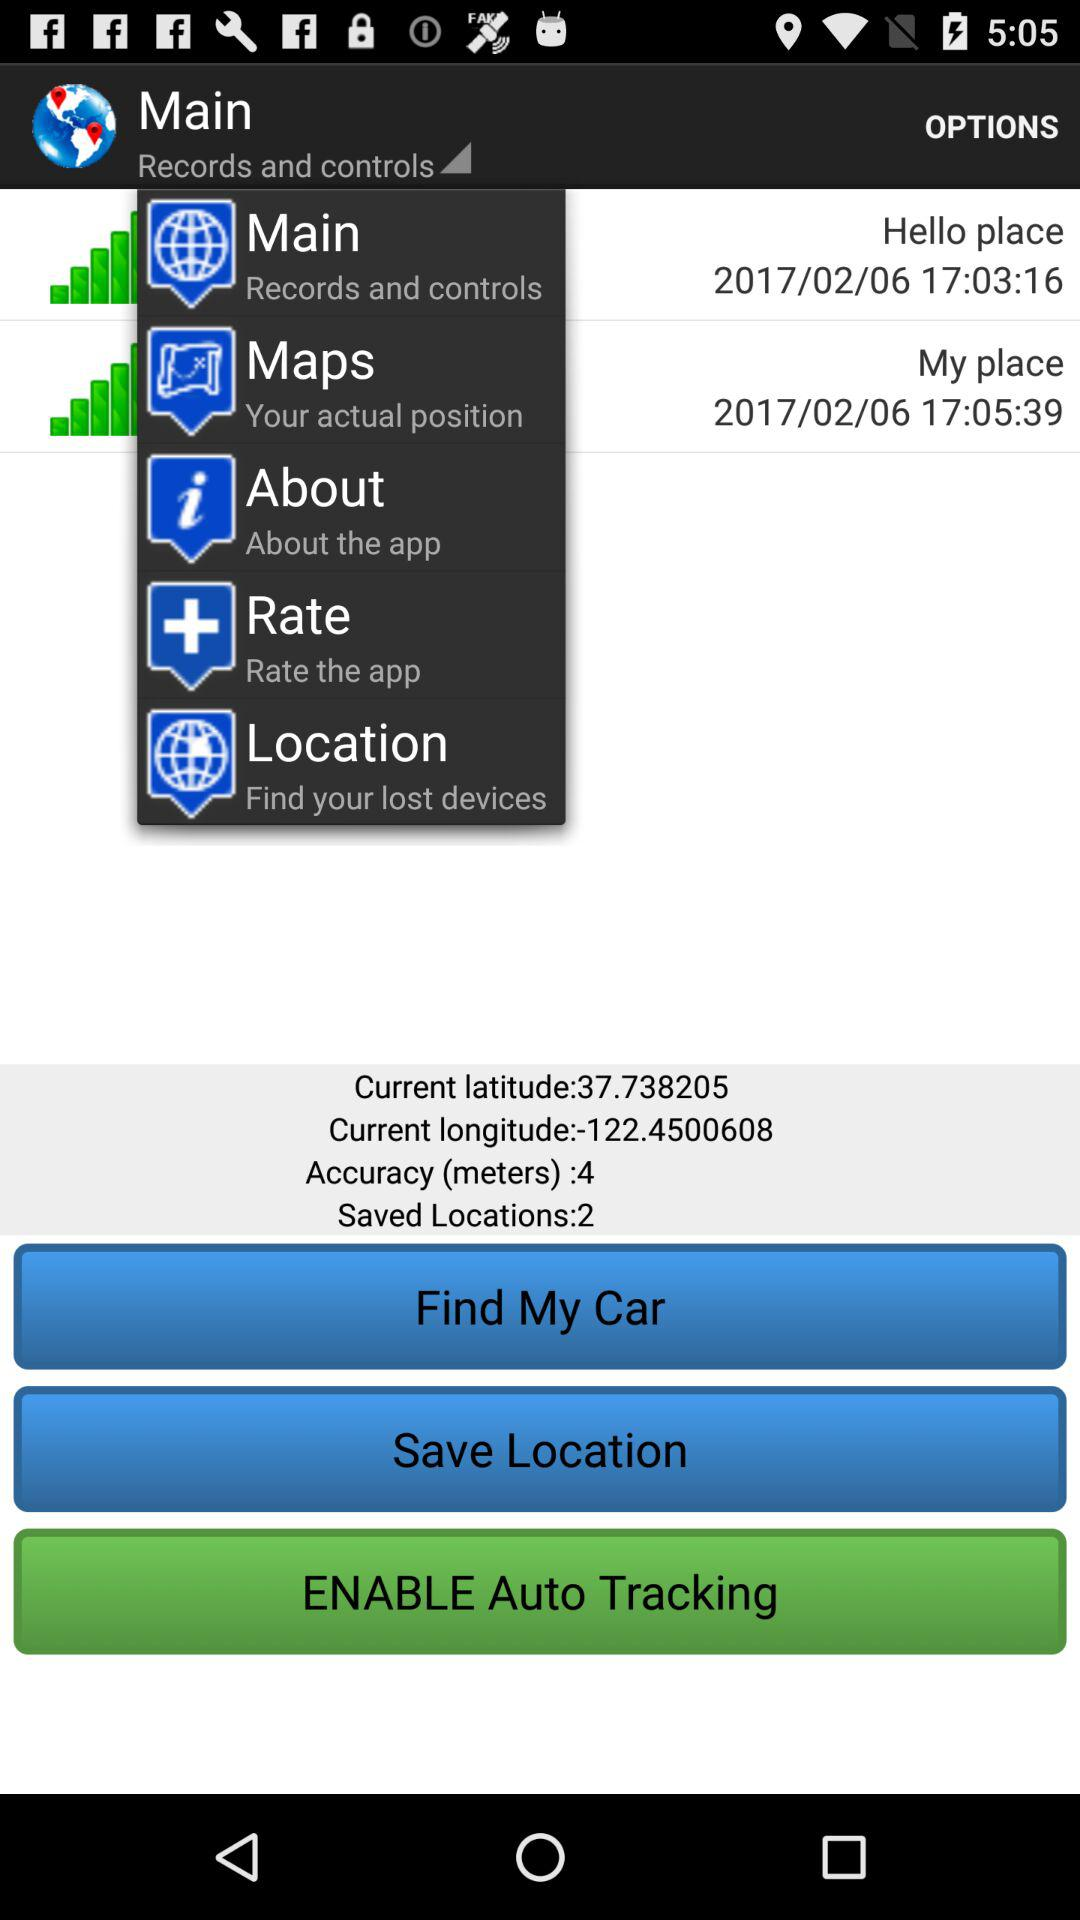What is the date and time of "My place"? The date and time of "My place" are 2017/02/06 and 17:05:39 respectively. 